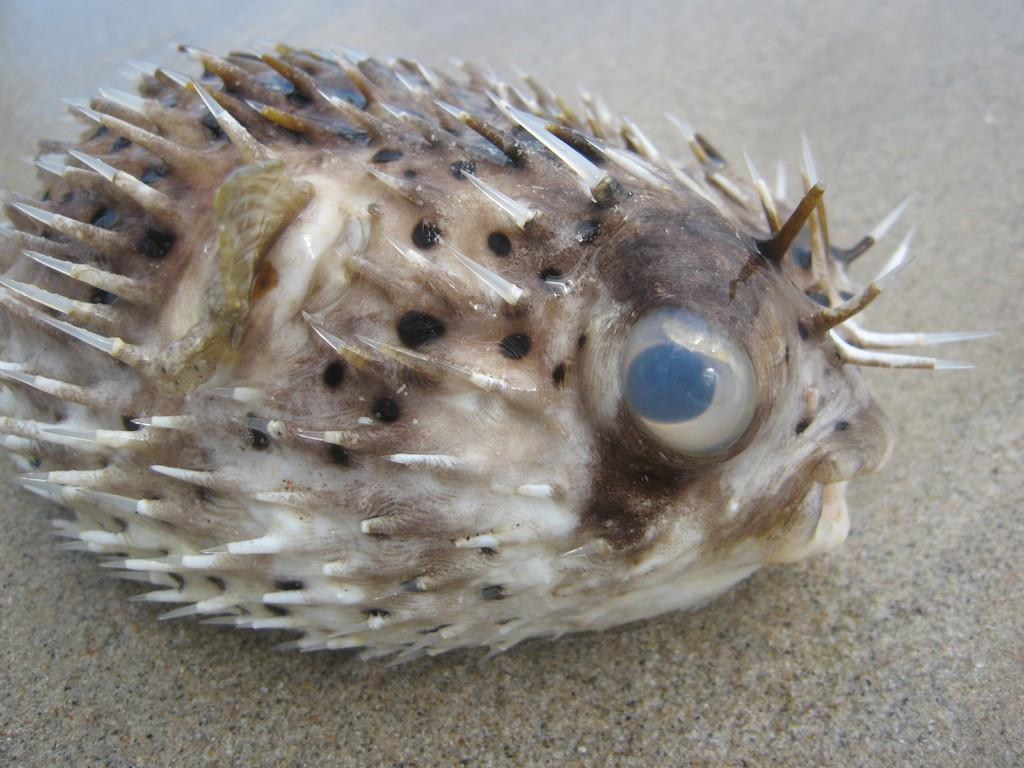What type of animal is in the image? There is a puffer fish in the image. Where is the puffer fish located in the image? The puffer fish is on the floor. What type of sponge can be seen hanging from the window in the image? There is no sponge or window present in the image; it only features a puffer fish on the floor. 